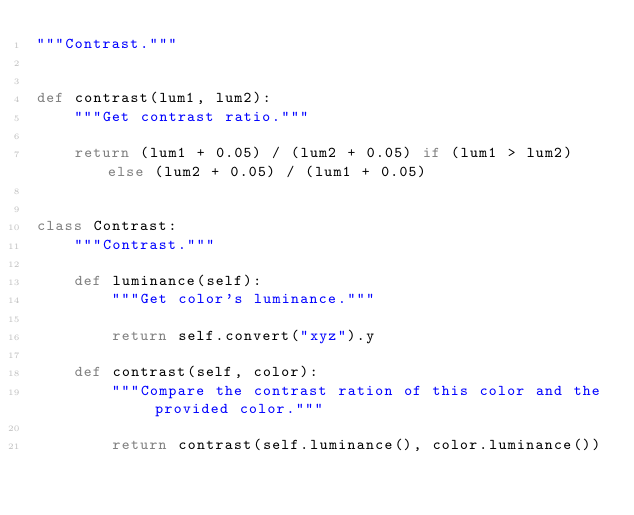<code> <loc_0><loc_0><loc_500><loc_500><_Python_>"""Contrast."""


def contrast(lum1, lum2):
    """Get contrast ratio."""

    return (lum1 + 0.05) / (lum2 + 0.05) if (lum1 > lum2) else (lum2 + 0.05) / (lum1 + 0.05)


class Contrast:
    """Contrast."""

    def luminance(self):
        """Get color's luminance."""

        return self.convert("xyz").y

    def contrast(self, color):
        """Compare the contrast ration of this color and the provided color."""

        return contrast(self.luminance(), color.luminance())
</code> 